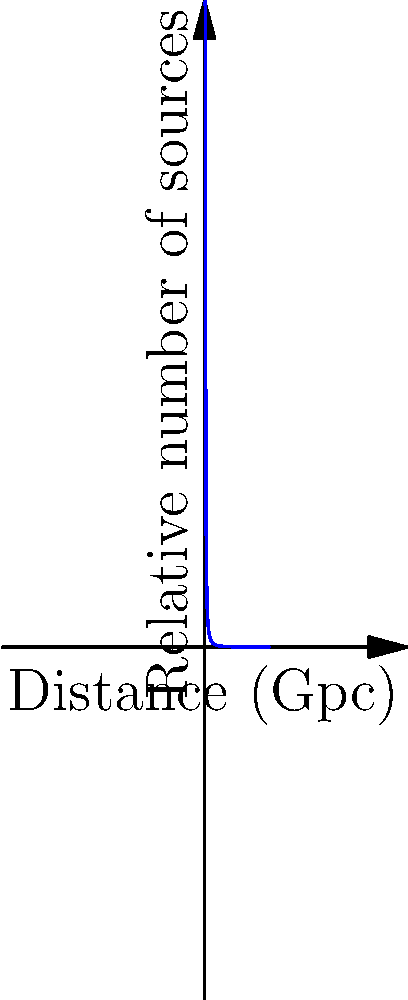Based on the graph showing the relative number of gravitational wave sources as a function of distance, what does this distribution imply about the detectability of gravitational wave events in the observable universe? To understand the implications of this distribution, let's analyze the graph step-by-step:

1. The x-axis represents the distance in gigaparsecs (Gpc), while the y-axis shows the relative number of sources.

2. The curve follows an inverse square law: $f(x) = \frac{1}{x^2}$, where x is the distance.

3. This distribution implies that:
   a) There are more nearby sources than distant ones.
   b) The number of sources decreases rapidly with increasing distance.

4. The inverse square law can be explained by two factors:
   a) The volume of space increases as $r^3$, where r is the radius.
   b) The flux (or detectability) of gravitational waves decreases as $\frac{1}{r^2}$.

5. Combining these factors: $\text{Number of detectable sources} \propto \frac{r^3}{r^2} = r$

6. However, cosmological effects (e.g., redshift, expansion of the universe) further reduce the detectability of distant sources, leading to the observed $\frac{1}{r^2}$ relationship.

7. The "Observable horizon" marked on the graph indicates the limit of our ability to detect gravitational wave sources due to the expansion of the universe and instrumental sensitivity.

8. This distribution suggests that most detectable gravitational wave events will come from relatively nearby sources, within a few Gpc of Earth.

9. Detecting very distant sources becomes increasingly difficult due to their weaker signals and the cosmological effects mentioned earlier.

This distribution is crucial for understanding the limitations and capabilities of current and future gravitational wave detectors, as well as for estimating the rate of detectable events.
Answer: Most detectable gravitational wave events will be from nearby sources, with detection becoming increasingly difficult at greater distances due to signal weakness and cosmological effects. 